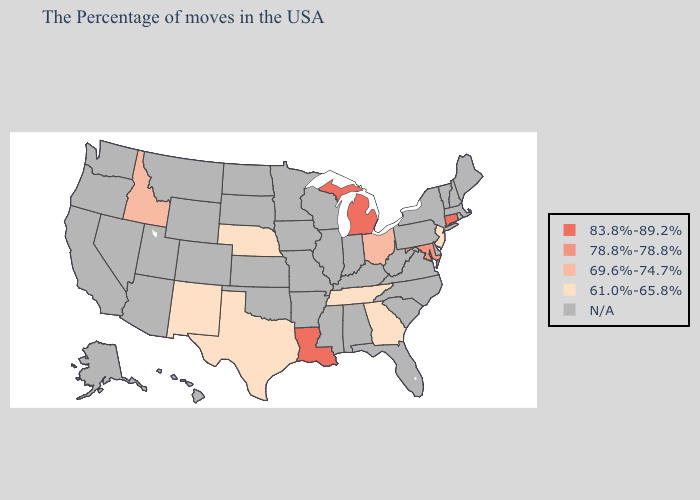What is the lowest value in states that border Florida?
Short answer required. 61.0%-65.8%. What is the lowest value in the South?
Be succinct. 61.0%-65.8%. Which states have the lowest value in the USA?
Be succinct. New Jersey, Georgia, Tennessee, Nebraska, Texas, New Mexico. Does New Jersey have the highest value in the Northeast?
Keep it brief. No. Is the legend a continuous bar?
Give a very brief answer. No. What is the value of New Hampshire?
Give a very brief answer. N/A. Does the map have missing data?
Keep it brief. Yes. Does Michigan have the highest value in the USA?
Answer briefly. Yes. Name the states that have a value in the range 83.8%-89.2%?
Short answer required. Connecticut, Michigan, Louisiana. Name the states that have a value in the range 78.8%-78.8%?
Write a very short answer. Maryland. What is the value of Maine?
Write a very short answer. N/A. Does Georgia have the highest value in the USA?
Write a very short answer. No. What is the value of Iowa?
Answer briefly. N/A. What is the highest value in the USA?
Keep it brief. 83.8%-89.2%. 